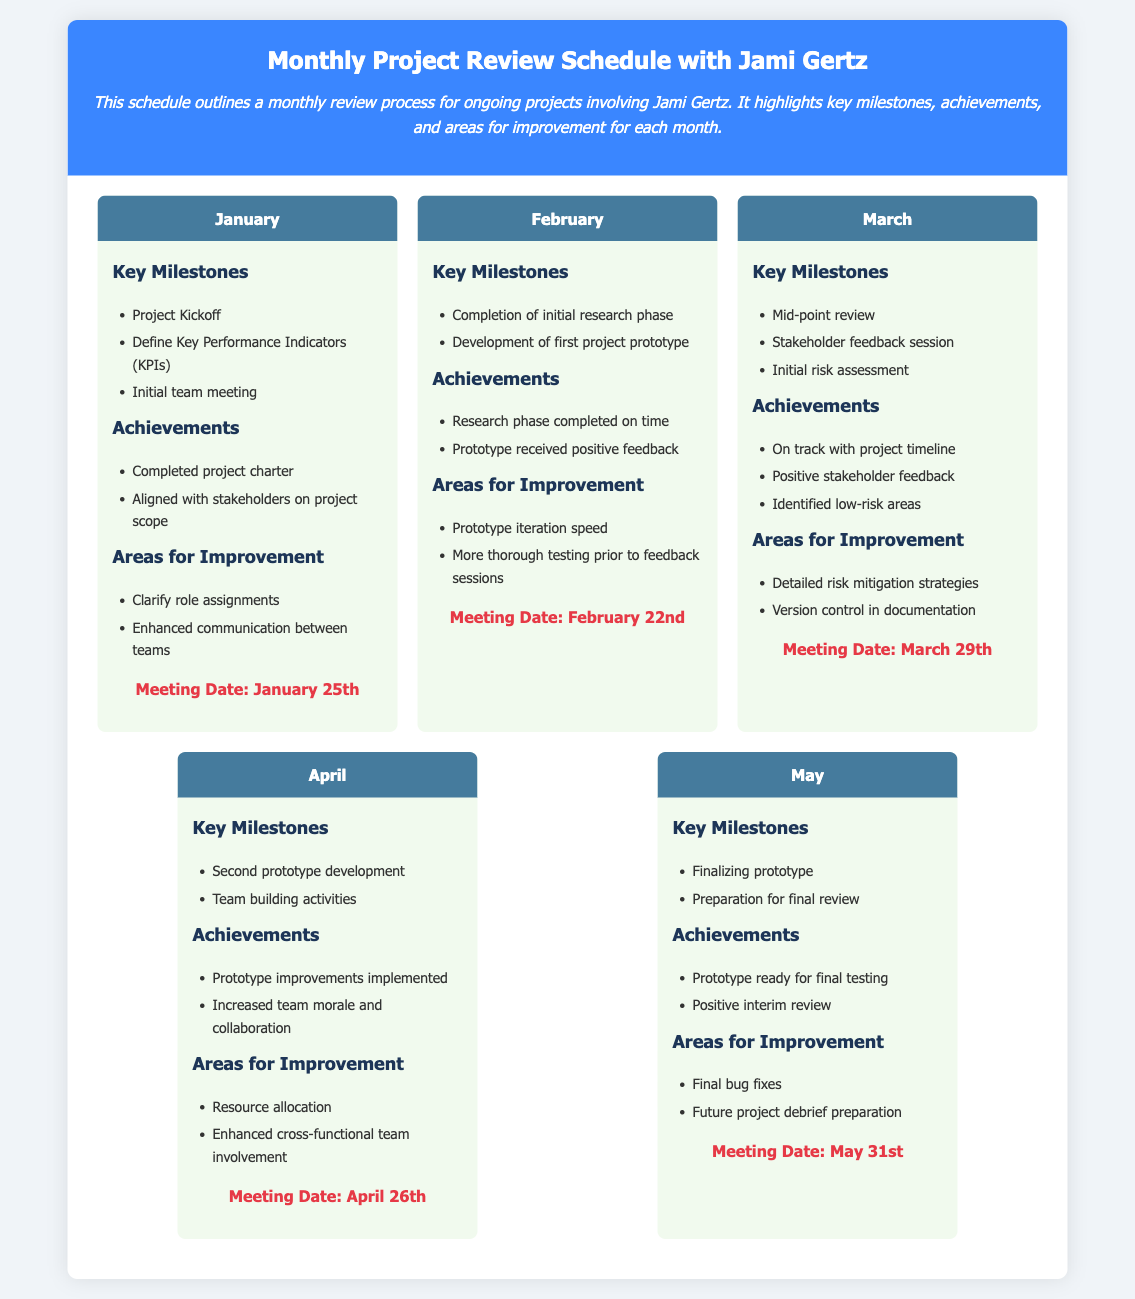What is the date of the January meeting? The document specifies the meeting date for January as January 25th.
Answer: January 25th What key milestone is noted for February? The document lists the completion of the initial research phase as a key milestone for February.
Answer: Completion of initial research phase What is one area for improvement listed in March? The document identifies "Detailed risk mitigation strategies" as an area for improvement in March.
Answer: Detailed risk mitigation strategies How many achievements are listed for April? The document details two achievements for April: "Prototype improvements implemented" and "Increased team morale and collaboration."
Answer: Two What is the key milestone for May? The document indicates "Finalizing prototype" as one of the key milestones for May.
Answer: Finalizing prototype What is the meeting date for April? The document notes that the meeting for April is scheduled for April 26th.
Answer: April 26th What is one achievement for February? The document states that a notable achievement for February is "Prototype received positive feedback."
Answer: Prototype received positive feedback What is the main focus of the monthly reviews? The document emphasizes that the monthly reviews are focused on "ongoing projects involving Jami Gertz."
Answer: Ongoing projects involving Jami Gertz Which month includes a stakeholder feedback session? The document specifies that the stakeholder feedback session takes place in March.
Answer: March 